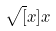Convert formula to latex. <formula><loc_0><loc_0><loc_500><loc_500>\sqrt { [ } x ] { x }</formula> 